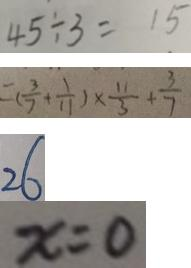<formula> <loc_0><loc_0><loc_500><loc_500>4 5 \div 3 = 1 5 
 = ( \frac { 3 } { 7 } + \frac { 1 } { 1 1 } ) \times \frac { 1 1 } { 3 } + \frac { 3 } { 7 } 
 2 6 
 x = 0</formula> 